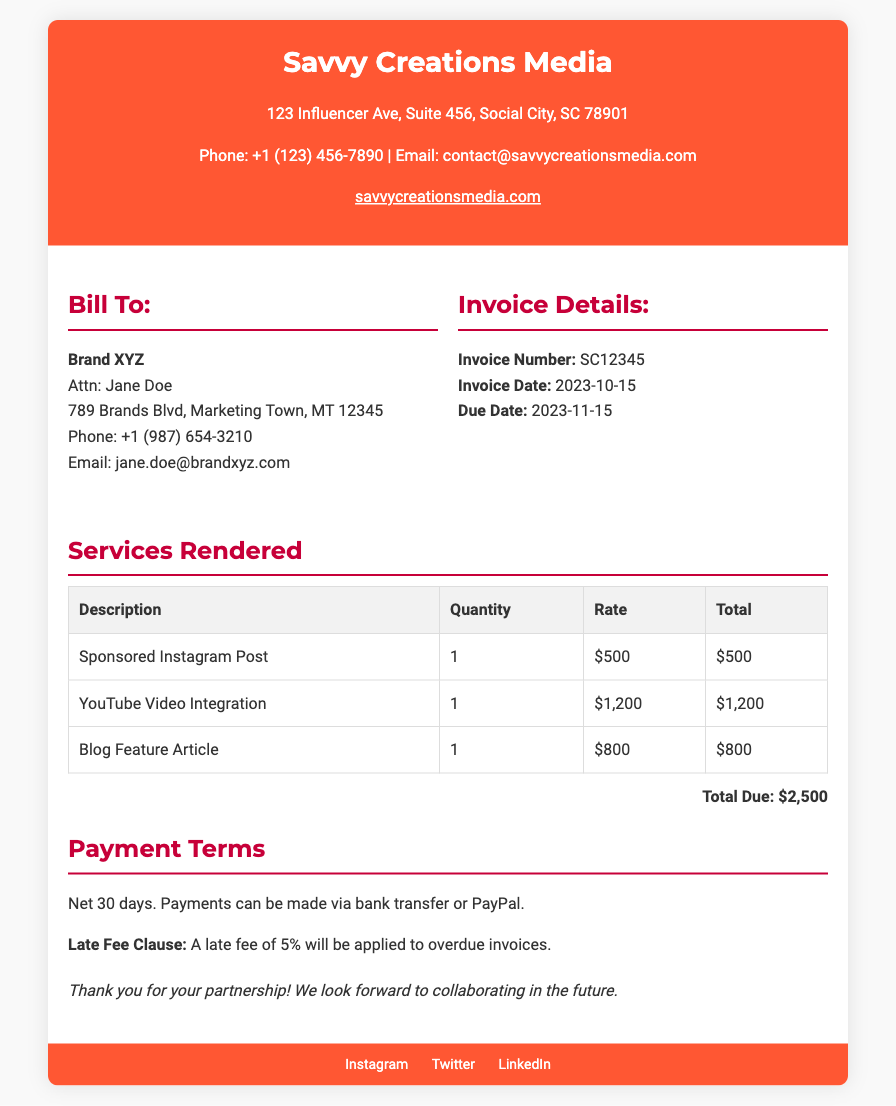What is the name of the company issuing the invoice? The company's name is prominently displayed at the top of the document as "Savvy Creations Media."
Answer: Savvy Creations Media Who is the invoice addressed to? The "Bill To" section of the document identifies the recipient as "Brand XYZ."
Answer: Brand XYZ What is the total amount due? The total due is clearly stated at the bottom of the "Services Rendered" section.
Answer: $2,500 What is the due date for the invoice? The due date is found in the "Invoice Details" section as listed.
Answer: 2023-11-15 How much is the payment to be made for the YouTube Video Integration? The table listing services rendered provides the payment amount for this specific service.
Answer: $1,200 What is the penalty for late payment? The document specifies that a late fee will be applied to overdue invoices, indicating the exact penalty.
Answer: 5% What are the accepted payment methods? The "Payment Terms" section outlines the methods that can be used for payment.
Answer: Bank transfer or PayPal What is the invoice number? The unique invoice number can be found in the "Invoice Details" section.
Answer: SC12345 